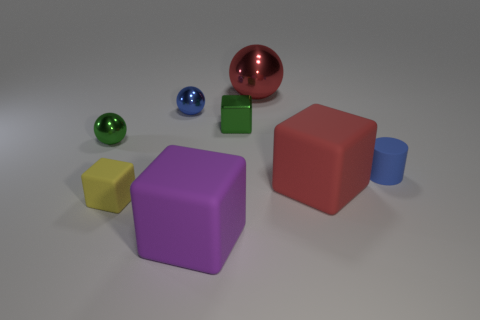There is a large matte cube behind the big rubber object that is to the left of the red matte block; what is its color?
Your answer should be very brief. Red. Do the purple object and the large red object in front of the small rubber cylinder have the same shape?
Provide a succinct answer. Yes. There is a green object that is to the left of the small green metal object on the right side of the cube that is to the left of the purple thing; what is it made of?
Keep it short and to the point. Metal. Is there a purple matte thing of the same size as the red shiny object?
Keep it short and to the point. Yes. What is the size of the cube that is the same material as the green ball?
Provide a short and direct response. Small. The purple rubber object is what shape?
Keep it short and to the point. Cube. Does the purple thing have the same material as the blue object that is left of the red sphere?
Your response must be concise. No. What number of objects are small cylinders or tiny brown shiny spheres?
Offer a very short reply. 1. Are any small yellow matte cylinders visible?
Ensure brevity in your answer.  No. The tiny object in front of the block on the right side of the red metallic sphere is what shape?
Your answer should be compact. Cube. 